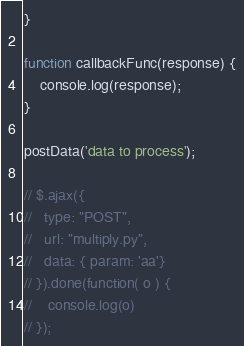Convert code to text. <code><loc_0><loc_0><loc_500><loc_500><_JavaScript_>}

function callbackFunc(response) {
    console.log(response);
}

postData('data to process');

// $.ajax({
//   type: "POST",
//   url: "multiply.py",
//   data: { param: 'aa'}
// }).done(function( o ) {
//    console.log(o)
// });</code> 